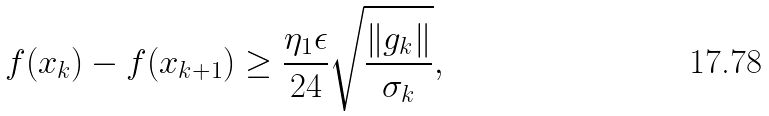Convert formula to latex. <formula><loc_0><loc_0><loc_500><loc_500>f ( x _ { k } ) - f ( x _ { k + 1 } ) \geq \frac { \eta _ { 1 } \epsilon } { 2 4 } \sqrt { \frac { \| g _ { k } \| } { \sigma _ { k } } } ,</formula> 